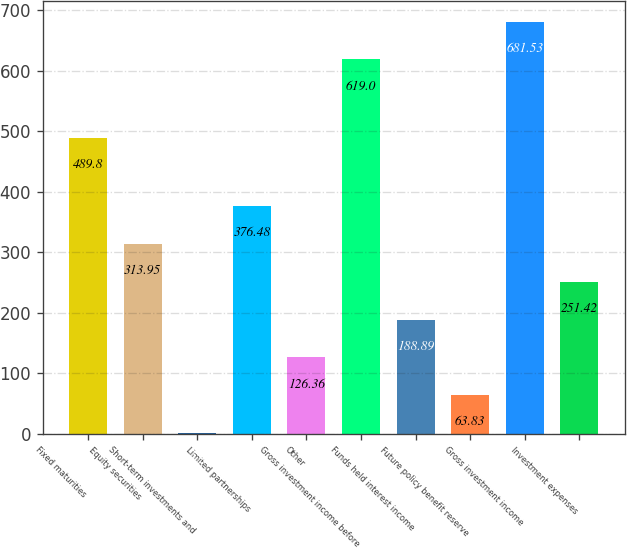Convert chart to OTSL. <chart><loc_0><loc_0><loc_500><loc_500><bar_chart><fcel>Fixed maturities<fcel>Equity securities<fcel>Short-term investments and<fcel>Limited partnerships<fcel>Other<fcel>Gross investment income before<fcel>Funds held interest income<fcel>Future policy benefit reserve<fcel>Gross investment income<fcel>Investment expenses<nl><fcel>489.8<fcel>313.95<fcel>1.3<fcel>376.48<fcel>126.36<fcel>619<fcel>188.89<fcel>63.83<fcel>681.53<fcel>251.42<nl></chart> 